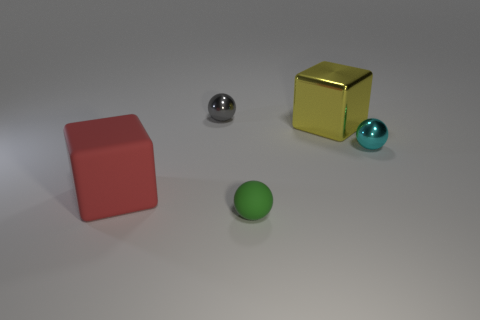Add 3 small cyan things. How many objects exist? 8 Subtract all balls. How many objects are left? 2 Add 4 tiny gray metal objects. How many tiny gray metal objects are left? 5 Add 5 tiny gray objects. How many tiny gray objects exist? 6 Subtract 0 green cubes. How many objects are left? 5 Subtract all blue matte balls. Subtract all tiny green balls. How many objects are left? 4 